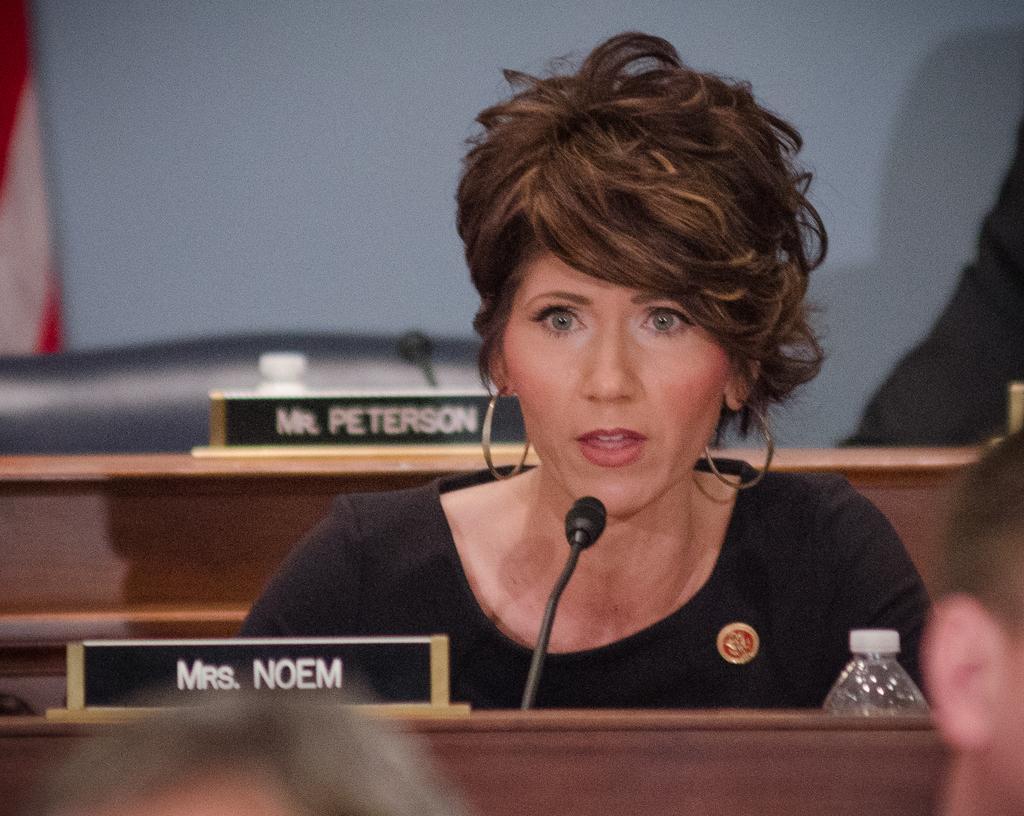How would you summarize this image in a sentence or two? In this image we can see a woman wearing black color dress sitting on the table, there is microphone, water bottle and some name boards in front of her and in the background of the image we can see some name board, water bottle and microphone. 